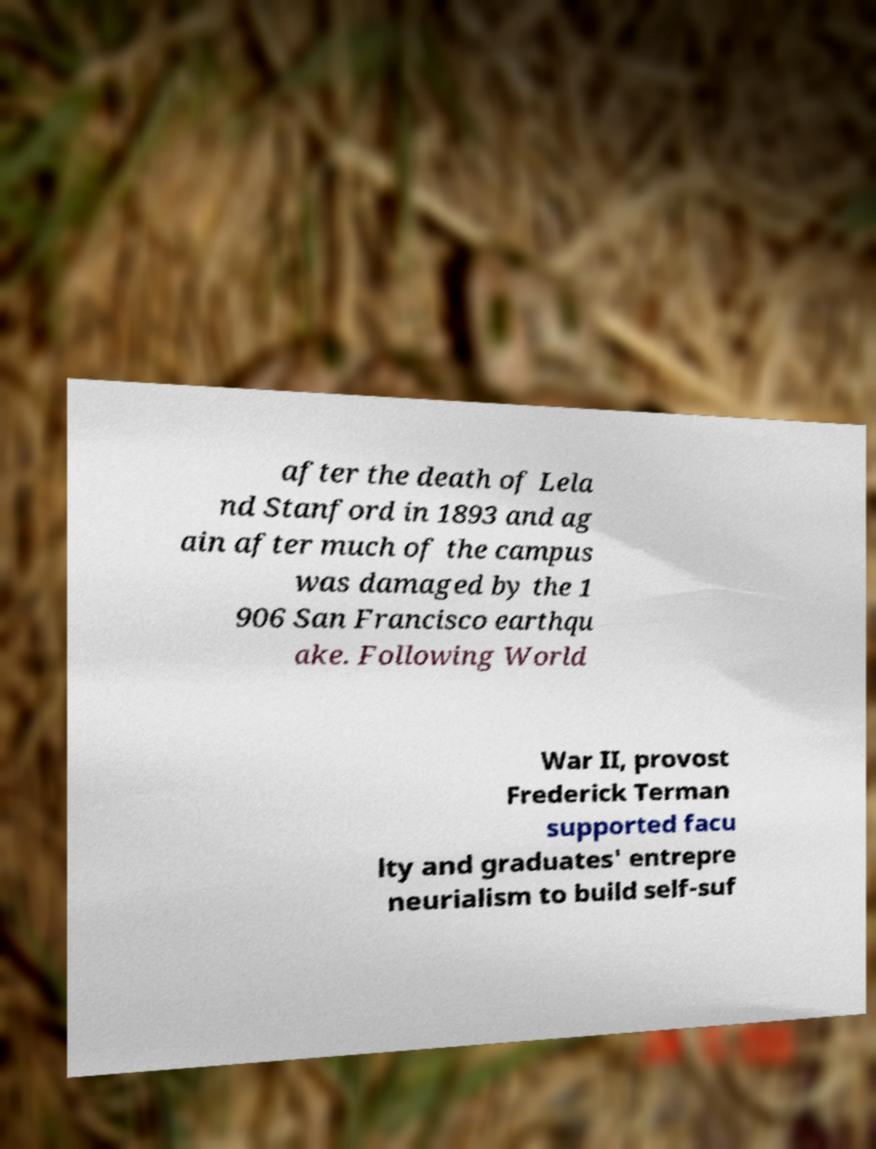I need the written content from this picture converted into text. Can you do that? after the death of Lela nd Stanford in 1893 and ag ain after much of the campus was damaged by the 1 906 San Francisco earthqu ake. Following World War II, provost Frederick Terman supported facu lty and graduates' entrepre neurialism to build self-suf 